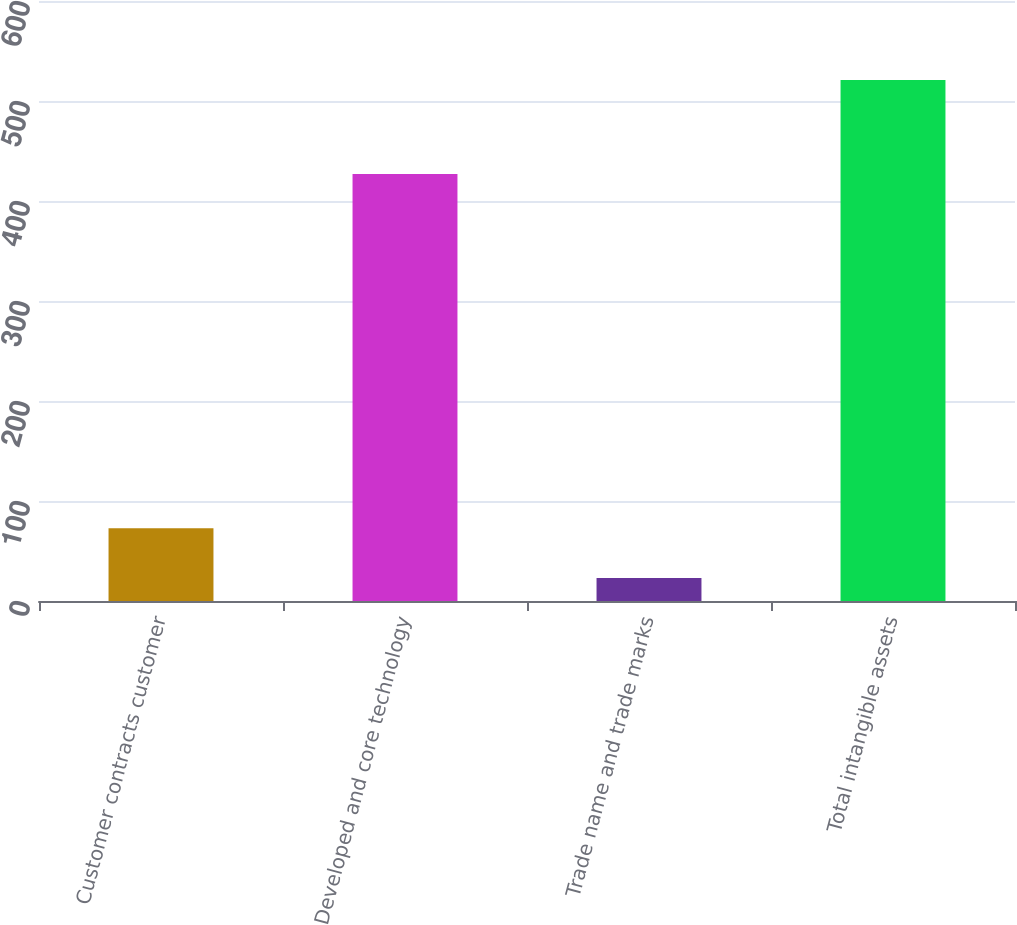Convert chart to OTSL. <chart><loc_0><loc_0><loc_500><loc_500><bar_chart><fcel>Customer contracts customer<fcel>Developed and core technology<fcel>Trade name and trade marks<fcel>Total intangible assets<nl><fcel>72.8<fcel>427<fcel>23<fcel>521<nl></chart> 